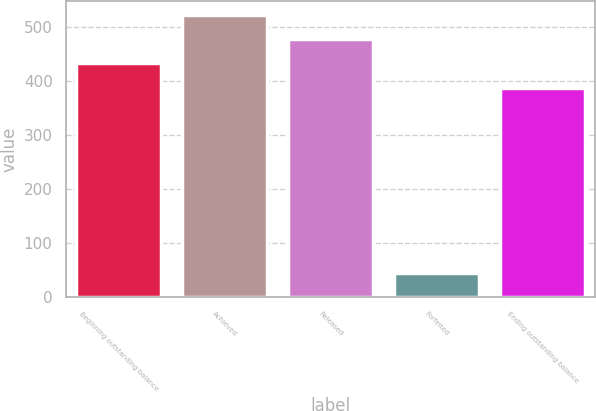<chart> <loc_0><loc_0><loc_500><loc_500><bar_chart><fcel>Beginning outstanding balance<fcel>Achieved<fcel>Released<fcel>Forfeited<fcel>Ending outstanding balance<nl><fcel>432.7<fcel>522.1<fcel>477.4<fcel>45<fcel>388<nl></chart> 